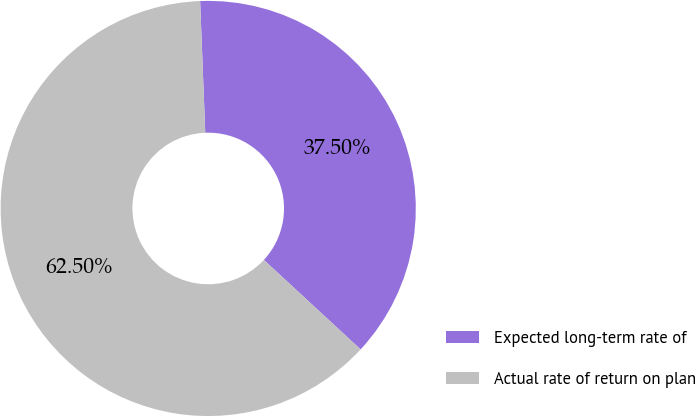Convert chart to OTSL. <chart><loc_0><loc_0><loc_500><loc_500><pie_chart><fcel>Expected long-term rate of<fcel>Actual rate of return on plan<nl><fcel>37.5%<fcel>62.5%<nl></chart> 